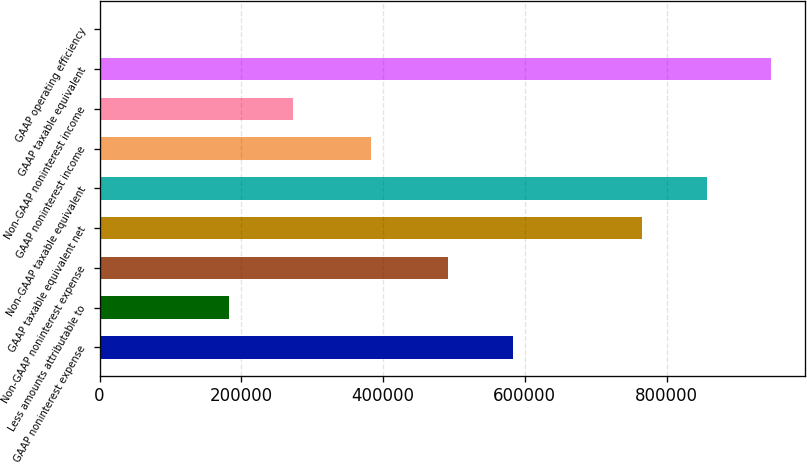Convert chart to OTSL. <chart><loc_0><loc_0><loc_500><loc_500><bar_chart><fcel>GAAP noninterest expense<fcel>Less amounts attributable to<fcel>Non-GAAP noninterest expense<fcel>GAAP taxable equivalent net<fcel>Non-GAAP taxable equivalent<fcel>GAAP noninterest income<fcel>Non-GAAP noninterest income<fcel>GAAP taxable equivalent<fcel>GAAP operating efficiency<nl><fcel>583234<fcel>182156<fcel>492184<fcel>765336<fcel>856386<fcel>382332<fcel>273206<fcel>947436<fcel>54.98<nl></chart> 